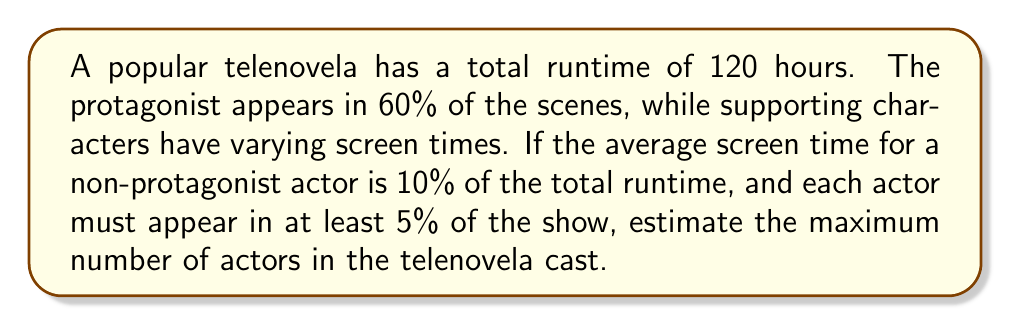Solve this math problem. Let's approach this step-by-step:

1) First, let's calculate the total screen time available for non-protagonist actors:
   - Total runtime = 120 hours
   - Protagonist's screen time = 60% of 120 hours = 0.6 × 120 = 72 hours
   - Remaining screen time = 120 - 72 = 48 hours

2) Now, we need to set up an equation to represent the inverse problem:
   Let $x$ be the number of non-protagonist actors.
   $$48 = 0.1 \times 120 \times x$$

   This equation states that the remaining 48 hours should be divided among $x$ actors, each getting an average of 10% of the total runtime.

3) Solve for $x$:
   $$x = \frac{48}{0.1 \times 120} = \frac{48}{12} = 4$$

4) However, this is the number of actors if they all had exactly 10% screen time. We need to consider the constraint that each actor must appear in at least 5% of the show.

5) With 5% minimum screen time:
   $$\text{Maximum number of actors} = \frac{48}{0.05 \times 120} = \frac{48}{6} = 8$$

6) Don't forget to add the protagonist to the total:
   Total maximum cast = 8 + 1 = 9
Answer: 9 actors 